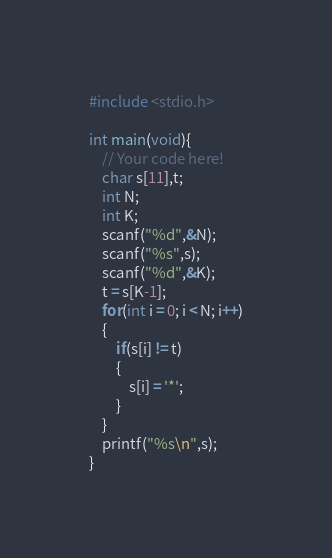Convert code to text. <code><loc_0><loc_0><loc_500><loc_500><_C_>#include <stdio.h>

int main(void){
    // Your code here!
    char s[11],t;
    int N;
    int K;
    scanf("%d",&N);
    scanf("%s",s);
    scanf("%d",&K);
    t = s[K-1];
    for(int i = 0; i < N; i++)
    {
        if(s[i] != t)
        {
            s[i] = '*';
        }
    }
    printf("%s\n",s);
}
</code> 